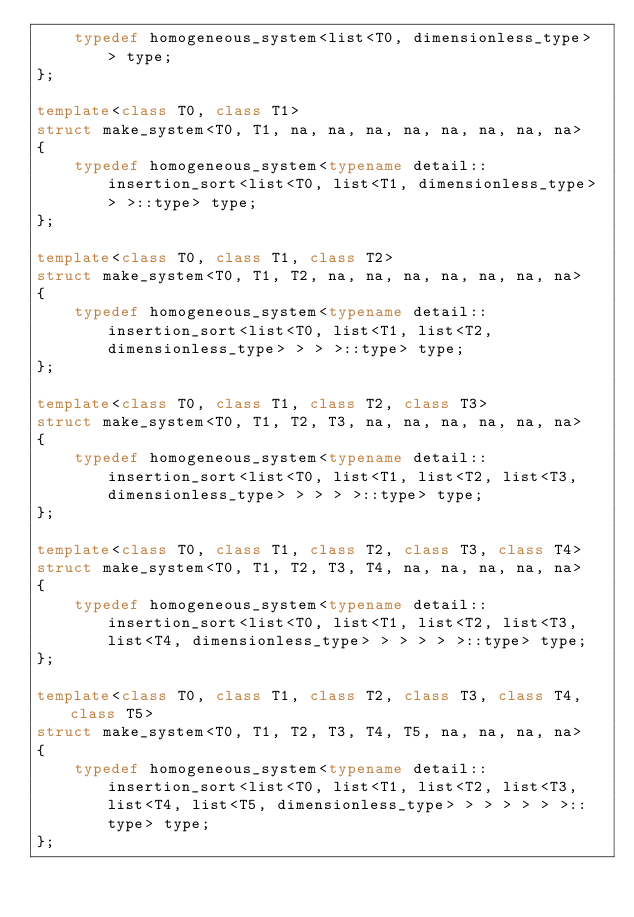Convert code to text. <code><loc_0><loc_0><loc_500><loc_500><_C++_>    typedef homogeneous_system<list<T0, dimensionless_type> > type;
};

template<class T0, class T1>
struct make_system<T0, T1, na, na, na, na, na, na, na, na>
{
    typedef homogeneous_system<typename detail::insertion_sort<list<T0, list<T1, dimensionless_type> > >::type> type;
};

template<class T0, class T1, class T2>
struct make_system<T0, T1, T2, na, na, na, na, na, na, na>
{
    typedef homogeneous_system<typename detail::insertion_sort<list<T0, list<T1, list<T2, dimensionless_type> > > >::type> type;
};

template<class T0, class T1, class T2, class T3>
struct make_system<T0, T1, T2, T3, na, na, na, na, na, na>
{
    typedef homogeneous_system<typename detail::insertion_sort<list<T0, list<T1, list<T2, list<T3, dimensionless_type> > > > >::type> type;
};

template<class T0, class T1, class T2, class T3, class T4>
struct make_system<T0, T1, T2, T3, T4, na, na, na, na, na>
{
    typedef homogeneous_system<typename detail::insertion_sort<list<T0, list<T1, list<T2, list<T3, list<T4, dimensionless_type> > > > > >::type> type;
};

template<class T0, class T1, class T2, class T3, class T4, class T5>
struct make_system<T0, T1, T2, T3, T4, T5, na, na, na, na>
{
    typedef homogeneous_system<typename detail::insertion_sort<list<T0, list<T1, list<T2, list<T3, list<T4, list<T5, dimensionless_type> > > > > > >::type> type;
};
</code> 